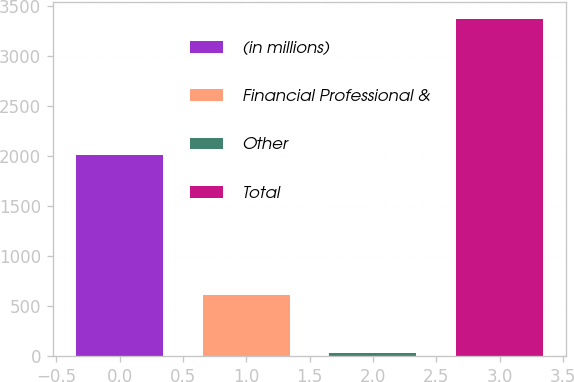Convert chart. <chart><loc_0><loc_0><loc_500><loc_500><bar_chart><fcel>(in millions)<fcel>Financial Professional &<fcel>Other<fcel>Total<nl><fcel>2012<fcel>613<fcel>27<fcel>3365<nl></chart> 